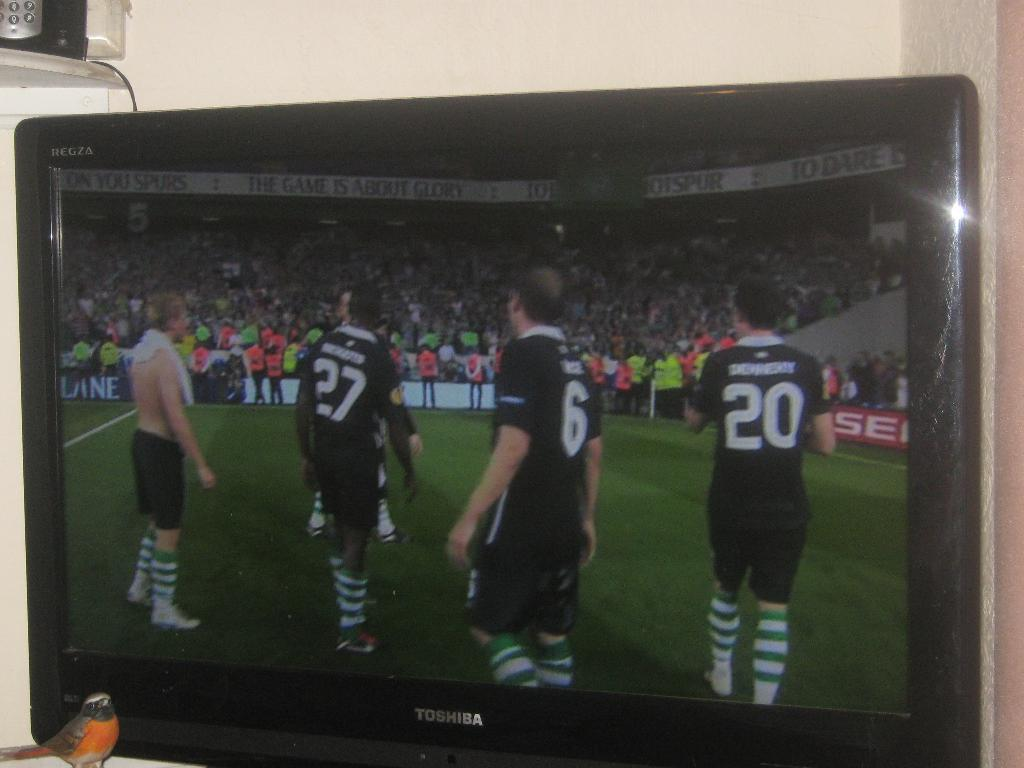<image>
Create a compact narrative representing the image presented. A black TV that says Toshiba on the front shows a soccer game in progress. 